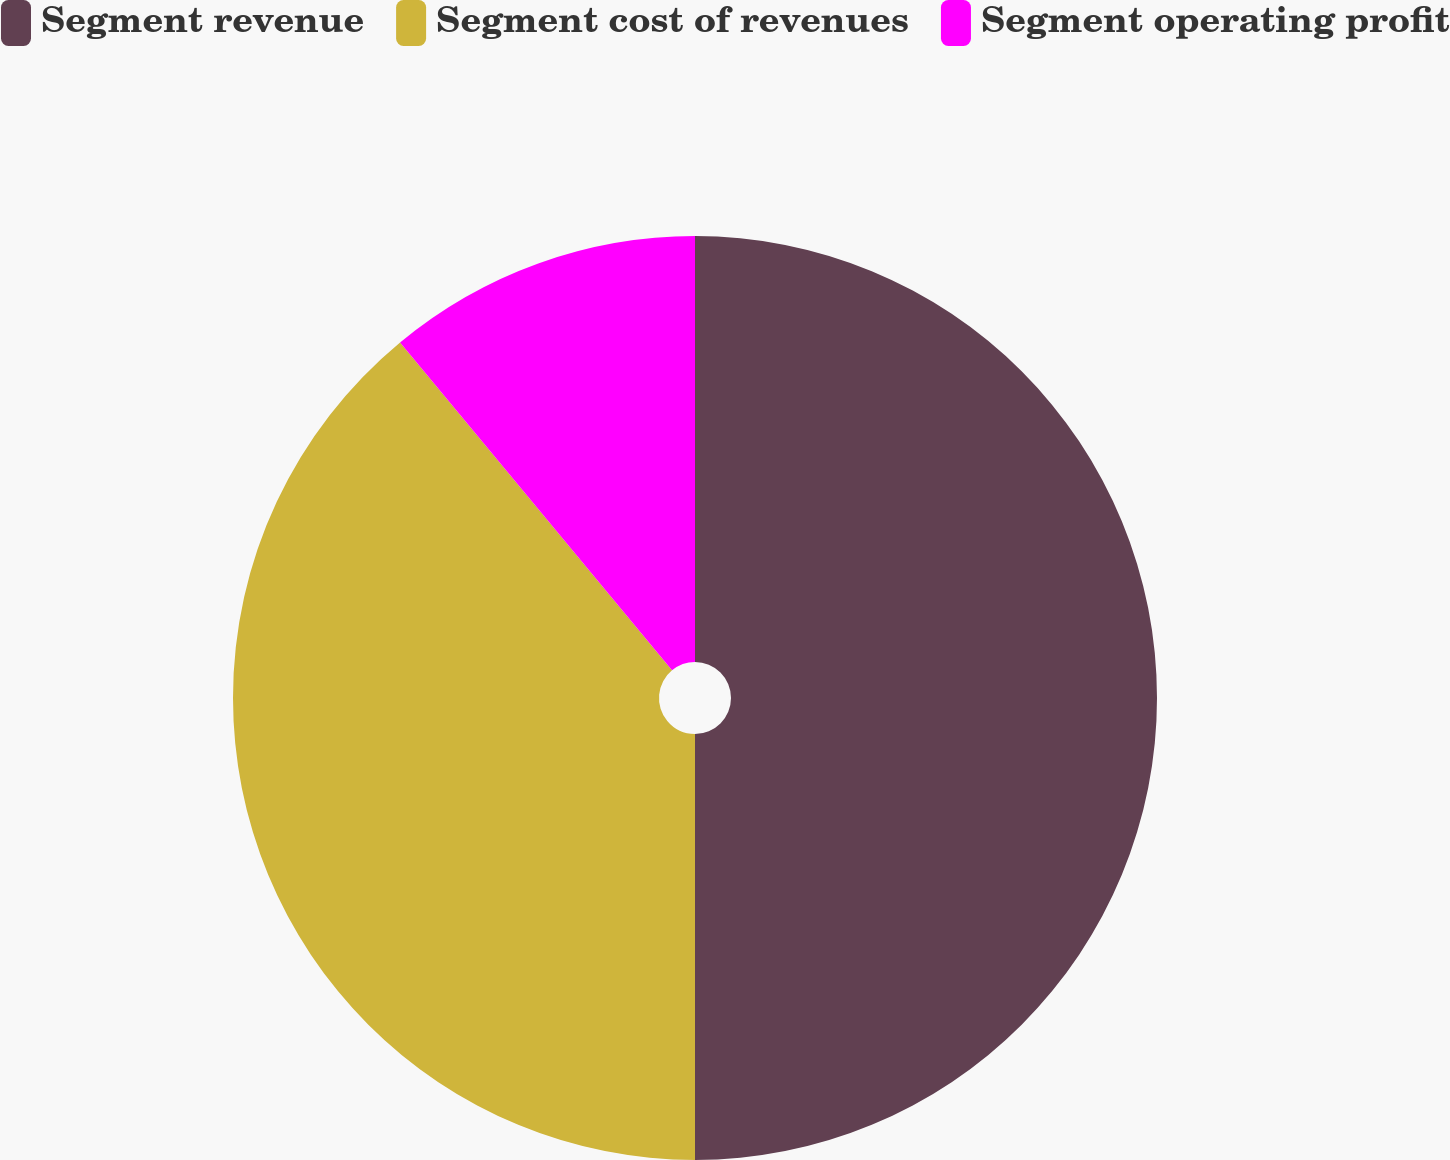<chart> <loc_0><loc_0><loc_500><loc_500><pie_chart><fcel>Segment revenue<fcel>Segment cost of revenues<fcel>Segment operating profit<nl><fcel>50.0%<fcel>38.98%<fcel>11.02%<nl></chart> 